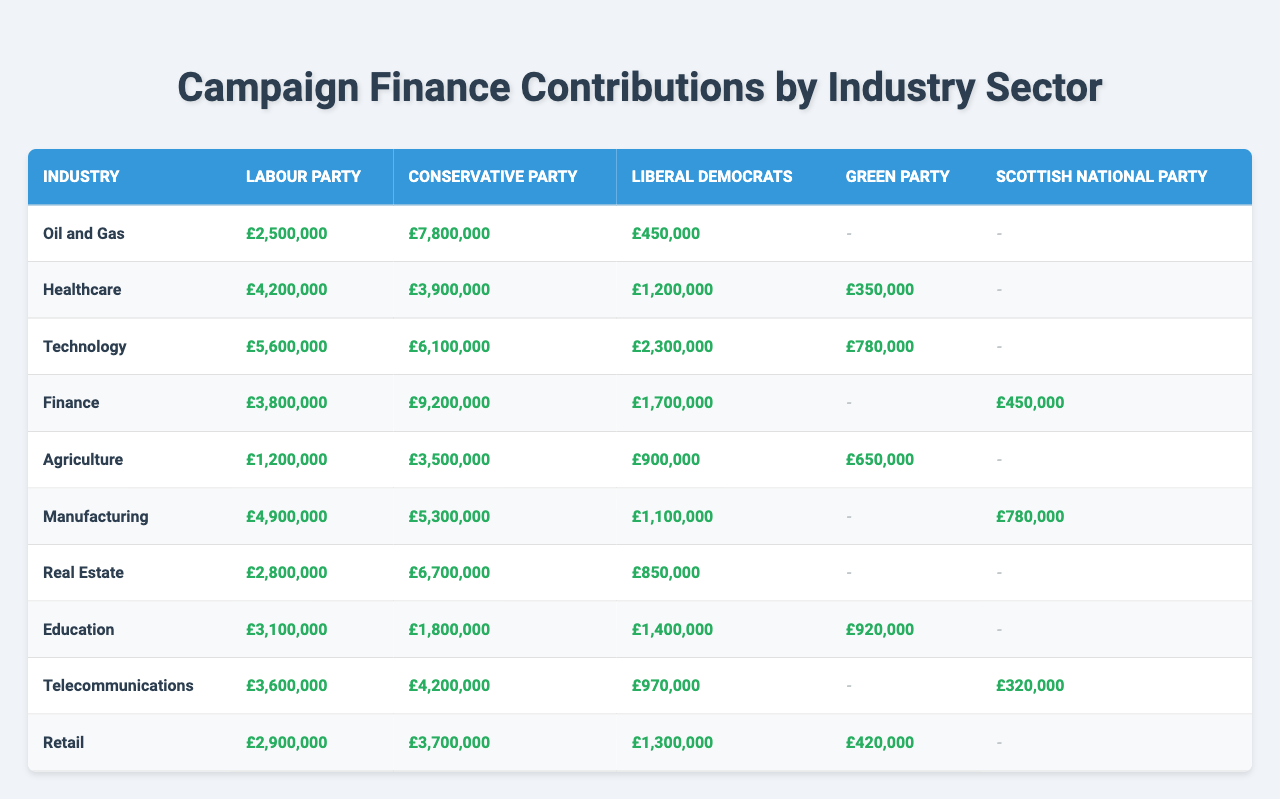What industry received the highest contributions from the Conservative Party? Looking at the Conservative Party column, we find that the total contributions for each industry. The highest contribution is from the Finance industry with £9,200,000.
Answer: £9,200,000 Which political party received more contributions from the Oil and Gas industry than from the Agriculture industry? In the table, the Labour Party received £2,500,000 from Oil and Gas and £1,200,000 from Agriculture. The Conservative Party received £7,800,000 from Oil and Gas and £3,500,000 from Agriculture. The Liberal Democrats received £450,000 from Oil and Gas and £900,000 from Agriculture. Thus, both the Labour and Conservative Parties received more from Oil and Gas.
Answer: Labour Party and Conservative Party What is the total contribution for the Liberal Democrats across all industries? To calculate this, we sum the contributions from each industry for the Liberal Democrats: £450,000 (Oil and Gas) + £1,200,000 (Healthcare) + £2,300,000 (Technology) + £1,700,000 (Finance) + £900,000 (Agriculture) + £1,100,000 (Manufacturing) + £850,000 (Real Estate) + £1,400,000 (Education) + £970,000 (Telecommunications) + £1,300,000 (Retail) = £12,700,000.
Answer: £12,700,000 Which industry contributed the least to the Green Party? Referring to the contributions for the Green Party, the lowest contribution comes from the Healthcare industry, which is £350,000.
Answer: £350,000 What is the average contribution of the Conservative Party across all industries? First, we sum the contributions from all industries: £7,800,000 (Oil and Gas) + £3,900,000 (Healthcare) + £6,100,000 (Technology) + £9,200,000 (Finance) + £3,500,000 (Agriculture) + £5,300,000 (Manufacturing) + £6,700,000 (Real Estate) + £1,800,000 (Education) + £4,200,000 (Telecommunications) + £3,700,000 (Retail) = £52,700,000. Then we divide by the number of industries (10), giving us an average of £5,270,000.
Answer: £5,270,000 Is it true that the Labour Party received contributions from the Telecommunications sector? Checking the Labour Party row under the Telecommunications sector, we see a contribution of £3,600,000. Therefore, it is true.
Answer: Yes Which party's total contributions exceed £10 million when combined from the Finance and Technology industries? The Conservative Party received £9,200,000 from Finance and £6,100,000 from Technology. Adding these gives £15,300,000, which exceeds £10 million. For Labour Party, £3,800,000 (Finance) + £5,600,000 (Technology) = £9,400,000. For Liberal Democrats, £1,700,000 (Finance) + £2,300,000 (Technology) = £4,000,000. The Scottish National Party received £450,000 from Finance and has no contribution from Technology, totaling £450,000. Hence, only Conservative Party exceeds £10 million.
Answer: Conservative Party Which industry has the second-lowest contribution for the Labour Party? For the Labour Party, the contributions are ranked as follows (from lowest to highest): £1,200,000 (Agriculture), £2,500,000 (Oil and Gas), £3,420,000 (Healthcare), £4,900,000 (Manufacturing), £5,600,000 (Technology), £3,100,000 (Education), £3,600,000 (Telecommunications), and £2,900,000 (Retail). The second-lowest is Agriculture with £1,200,000, and the lowest is Oil and Gas with £2,500,000.
Answer: £2,500,000 What is the difference between the highest and lowest contributions received by the Liberal Democrats? The highest contribution for the Liberal Democrats is £2,300,000 from the Technology industry, and the lowest is £450,000 from the Oil and Gas industry. The difference is £2,300,000 - £450,000 = £1,850,000.
Answer: £1,850,000 